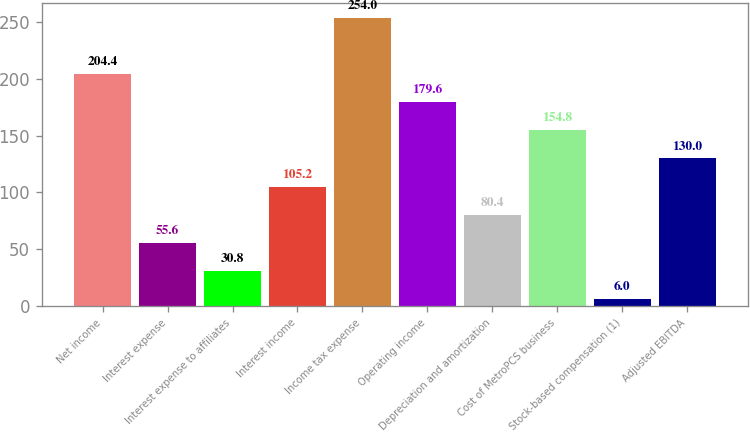Convert chart. <chart><loc_0><loc_0><loc_500><loc_500><bar_chart><fcel>Net income<fcel>Interest expense<fcel>Interest expense to affiliates<fcel>Interest income<fcel>Income tax expense<fcel>Operating income<fcel>Depreciation and amortization<fcel>Cost of MetroPCS business<fcel>Stock-based compensation (1)<fcel>Adjusted EBITDA<nl><fcel>204.4<fcel>55.6<fcel>30.8<fcel>105.2<fcel>254<fcel>179.6<fcel>80.4<fcel>154.8<fcel>6<fcel>130<nl></chart> 